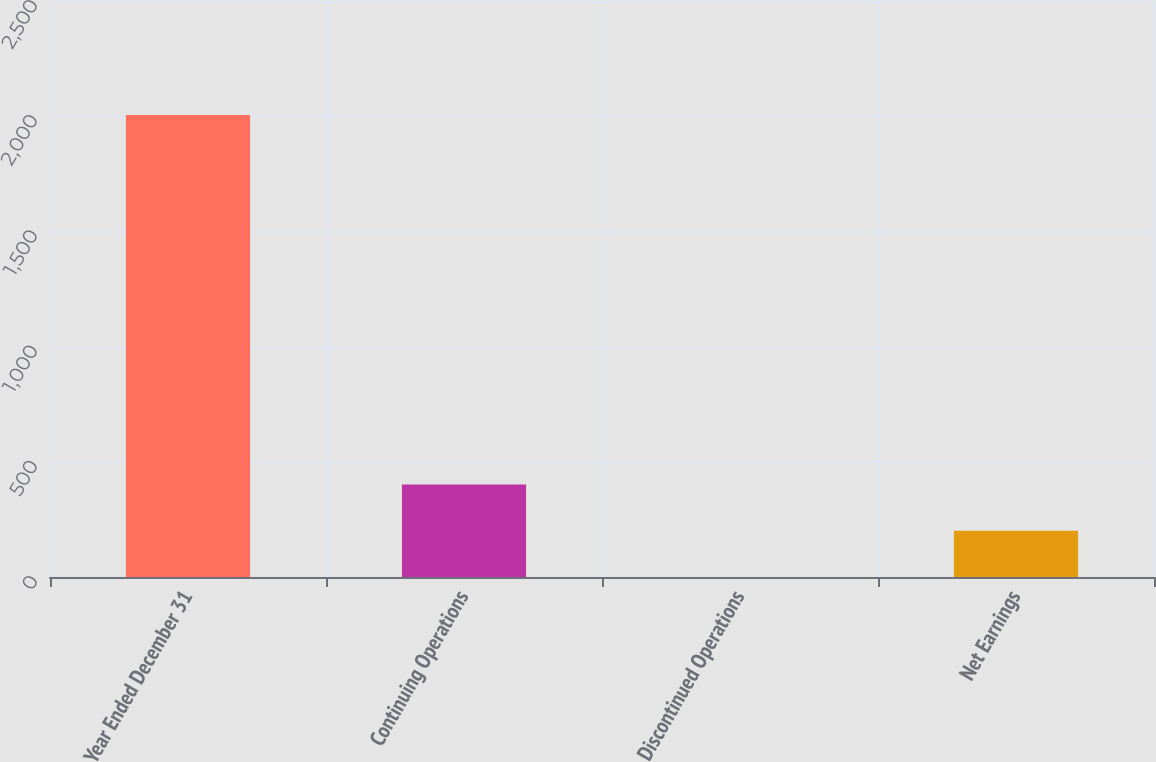<chart> <loc_0><loc_0><loc_500><loc_500><bar_chart><fcel>Year Ended December 31<fcel>Continuing Operations<fcel>Discontinued Operations<fcel>Net Earnings<nl><fcel>2005<fcel>401.02<fcel>0.02<fcel>200.52<nl></chart> 